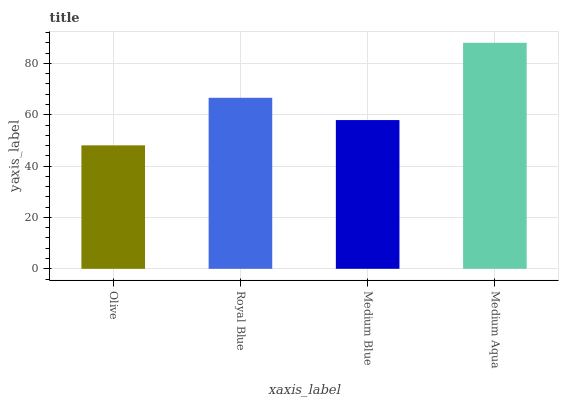Is Royal Blue the minimum?
Answer yes or no. No. Is Royal Blue the maximum?
Answer yes or no. No. Is Royal Blue greater than Olive?
Answer yes or no. Yes. Is Olive less than Royal Blue?
Answer yes or no. Yes. Is Olive greater than Royal Blue?
Answer yes or no. No. Is Royal Blue less than Olive?
Answer yes or no. No. Is Royal Blue the high median?
Answer yes or no. Yes. Is Medium Blue the low median?
Answer yes or no. Yes. Is Olive the high median?
Answer yes or no. No. Is Olive the low median?
Answer yes or no. No. 